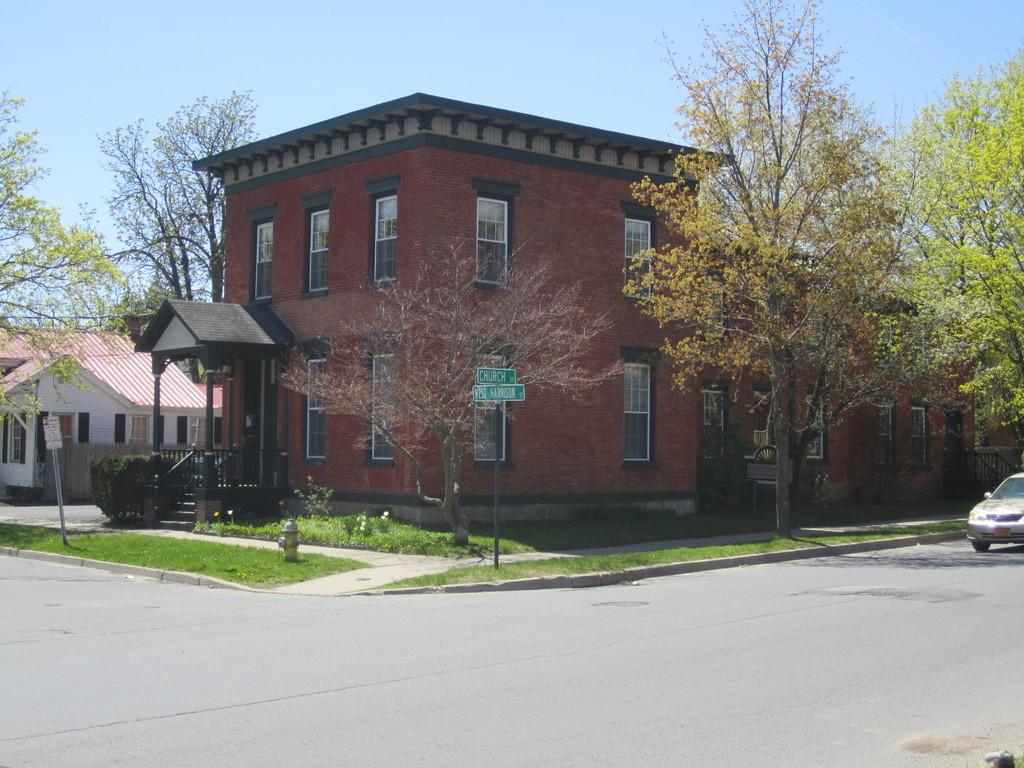What type of structures can be seen in the image? There are buildings in the image. Are there any indicators or markers visible in the image? Yes, there are sign boards in the image. What architectural feature is present in the image? There is a staircase in the image. What safety feature is present in the image? There are railings in the image. What type of emergency equipment is visible in the image? There is a hydrant in the image. What type of natural elements can be seen in the image? There are trees in the image. What part of the natural environment is visible in the image? The sky is visible in the image. What type of silk is being used to make the airport visible in the image? There is no silk or airport present in the image. What thought is being expressed by the trees in the image? Trees do not express thoughts; they are inanimate objects. 